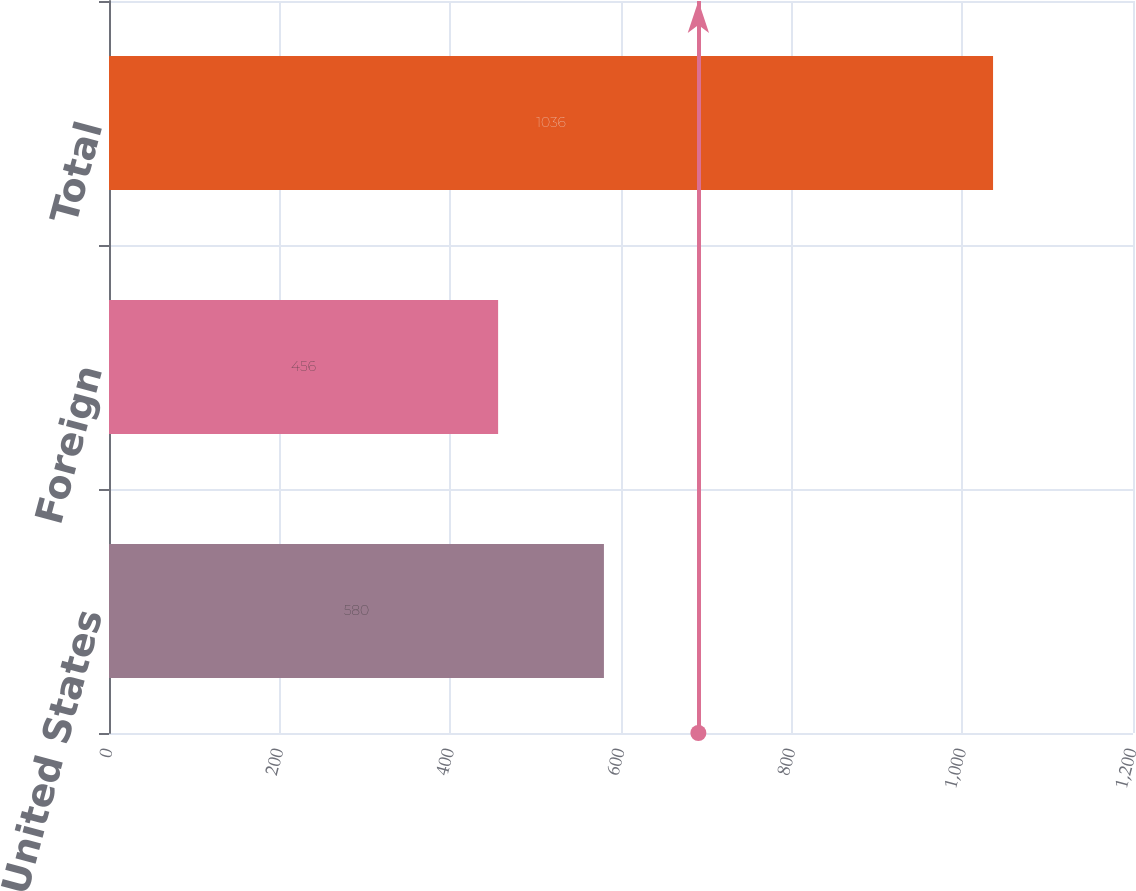Convert chart to OTSL. <chart><loc_0><loc_0><loc_500><loc_500><bar_chart><fcel>United States<fcel>Foreign<fcel>Total<nl><fcel>580<fcel>456<fcel>1036<nl></chart> 